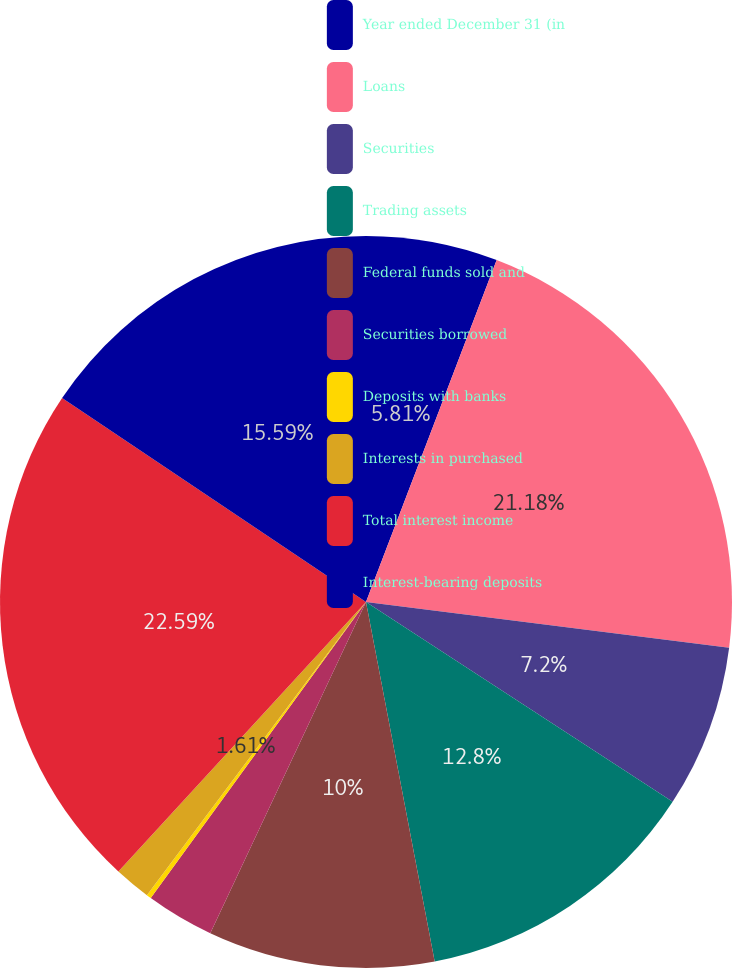<chart> <loc_0><loc_0><loc_500><loc_500><pie_chart><fcel>Year ended December 31 (in<fcel>Loans<fcel>Securities<fcel>Trading assets<fcel>Federal funds sold and<fcel>Securities borrowed<fcel>Deposits with banks<fcel>Interests in purchased<fcel>Total interest income<fcel>Interest-bearing deposits<nl><fcel>5.81%<fcel>21.18%<fcel>7.2%<fcel>12.8%<fcel>10.0%<fcel>3.01%<fcel>0.21%<fcel>1.61%<fcel>22.58%<fcel>15.59%<nl></chart> 